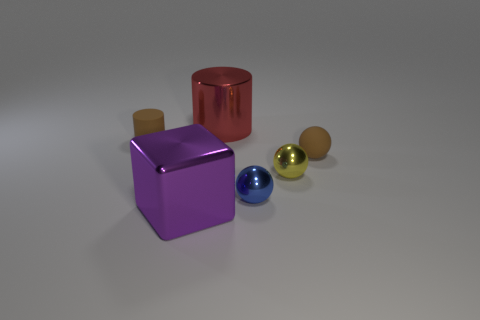What size is the yellow object in front of the cylinder that is behind the brown matte thing behind the tiny matte sphere?
Make the answer very short. Small. What number of large cylinders have the same material as the big purple thing?
Offer a very short reply. 1. Is the number of objects less than the number of green shiny balls?
Provide a succinct answer. No. What is the size of the brown rubber object that is the same shape as the large red thing?
Offer a very short reply. Small. Do the tiny brown object that is left of the large red metallic cylinder and the large cylinder have the same material?
Your answer should be very brief. No. Is the red thing the same shape as the big purple shiny thing?
Give a very brief answer. No. What number of things are either tiny brown objects that are on the right side of the small brown cylinder or large red things?
Provide a succinct answer. 2. The brown thing that is the same material as the tiny brown sphere is what size?
Provide a short and direct response. Small. How many matte balls have the same color as the small matte cylinder?
Keep it short and to the point. 1. What number of big objects are either yellow metallic things or blue metallic objects?
Provide a succinct answer. 0. 